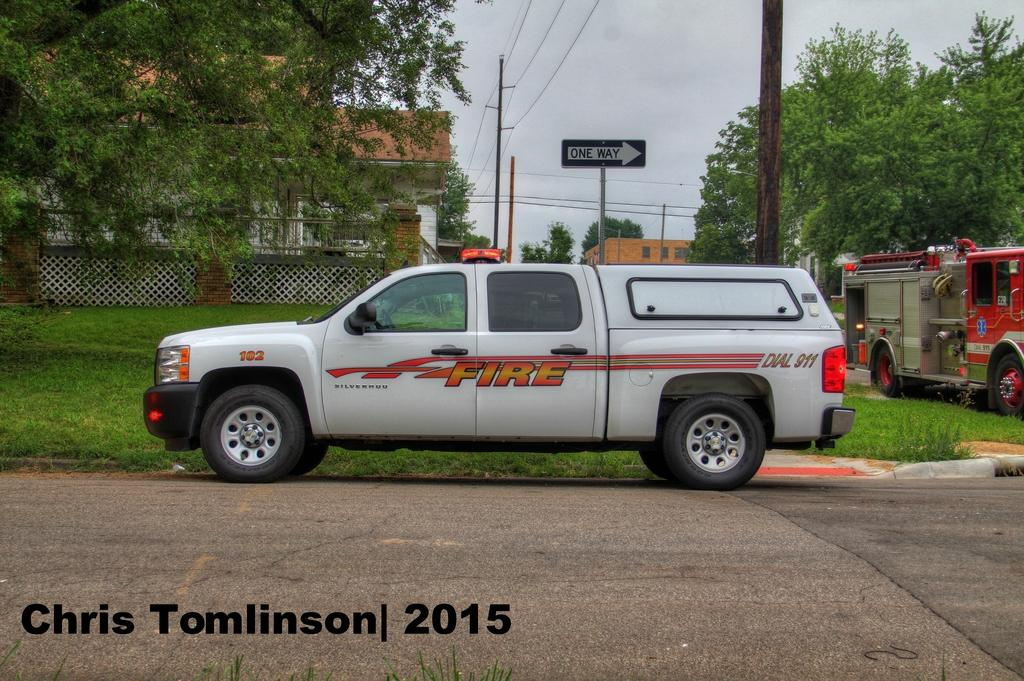What type of vehicles can be seen in the image? There are colorful vehicles in the image. What can be seen in the background of the image? There are boards and poles in the background of the image. What type of natural environment is visible in the image? There are many trees visible in the image. Can any structures be identified in the image? Yes, there is at least one building present in the image. What part of the natural environment is visible in the image? The sky is visible in the image. What is the amount of education provided by the plough in the image? There is no plough present in the image, and therefore no education can be provided by it. 